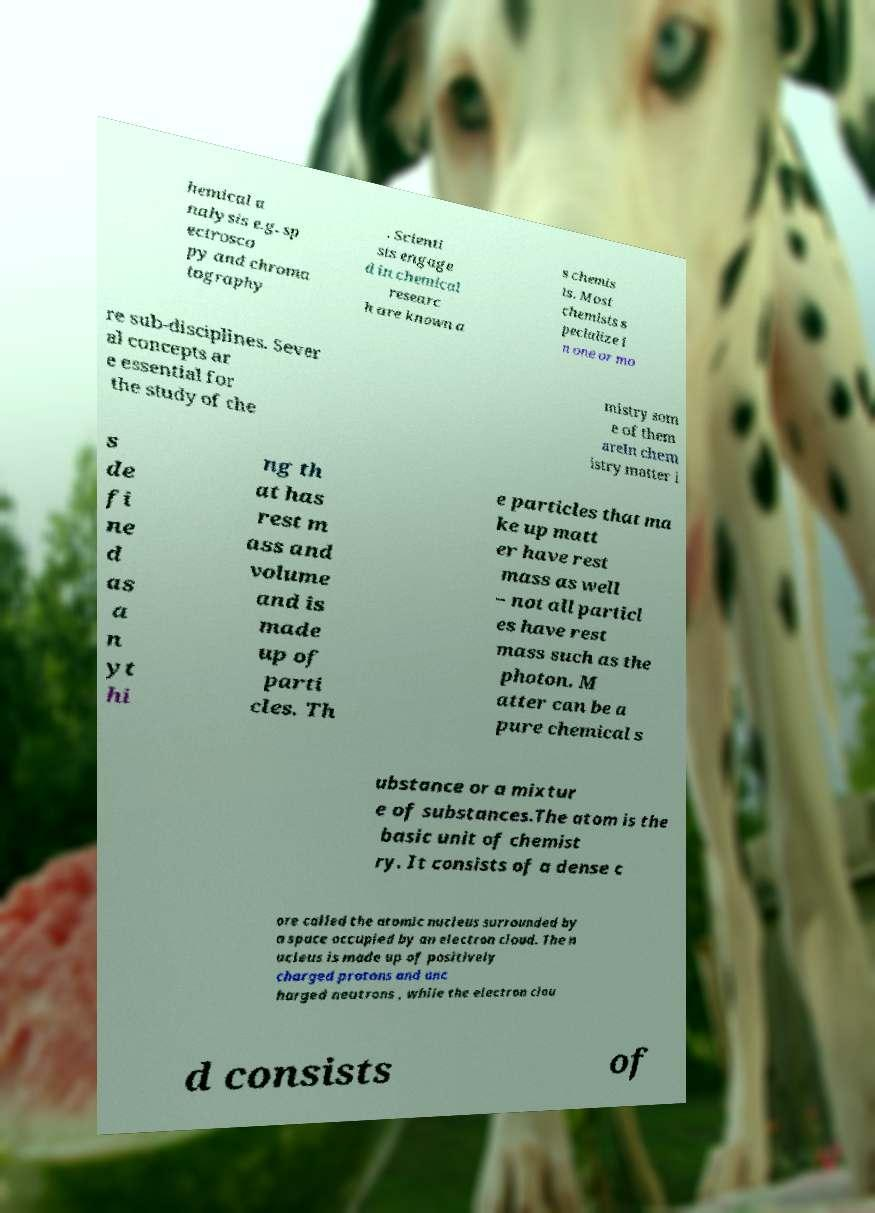Can you accurately transcribe the text from the provided image for me? hemical a nalysis e.g. sp ectrosco py and chroma tography . Scienti sts engage d in chemical researc h are known a s chemis ts. Most chemists s pecialize i n one or mo re sub-disciplines. Sever al concepts ar e essential for the study of che mistry som e of them areIn chem istry matter i s de fi ne d as a n yt hi ng th at has rest m ass and volume and is made up of parti cles. Th e particles that ma ke up matt er have rest mass as well – not all particl es have rest mass such as the photon. M atter can be a pure chemical s ubstance or a mixtur e of substances.The atom is the basic unit of chemist ry. It consists of a dense c ore called the atomic nucleus surrounded by a space occupied by an electron cloud. The n ucleus is made up of positively charged protons and unc harged neutrons , while the electron clou d consists of 